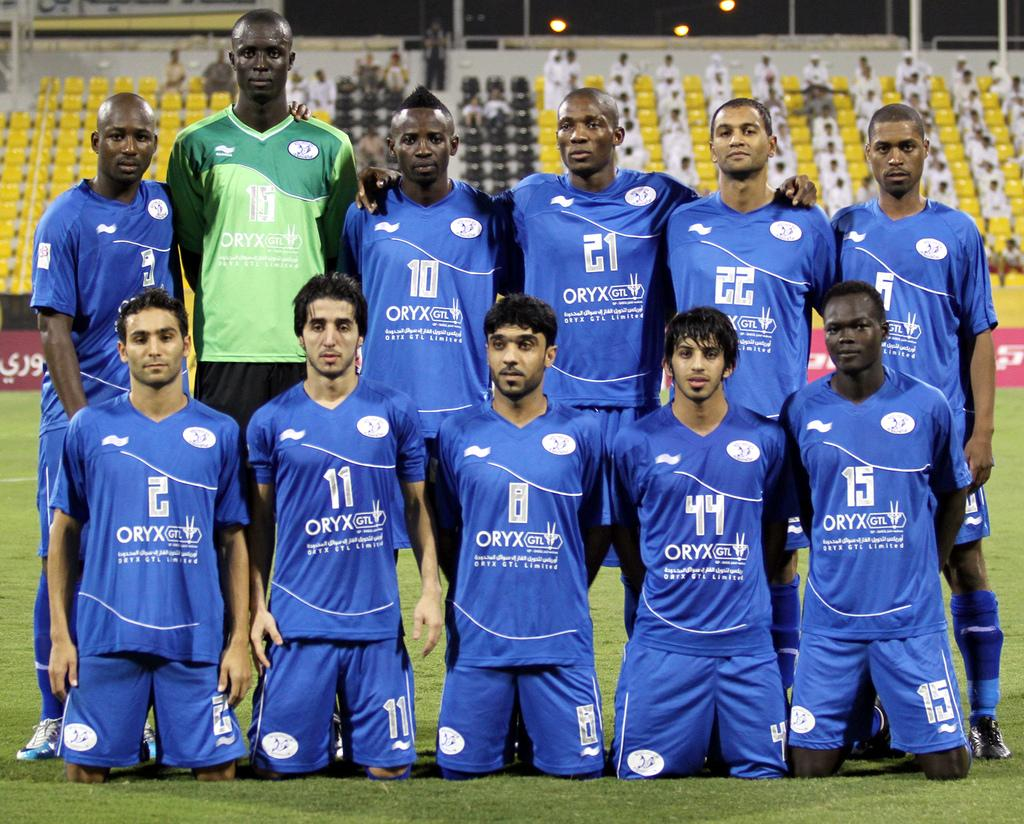<image>
Create a compact narrative representing the image presented. A soccer team posed for a picture in blue uniforms and the numbers 2,11, 44 and 15 in front. 